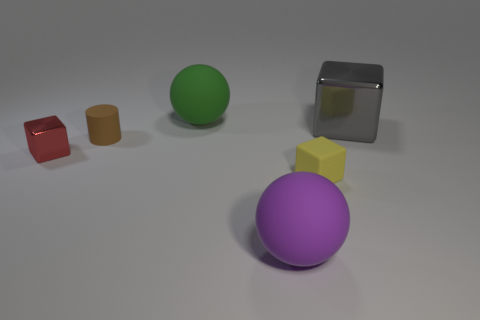Is there a tiny red block that has the same material as the big block?
Provide a short and direct response. Yes. What is the material of the red object that is the same size as the rubber cube?
Ensure brevity in your answer.  Metal. There is a matte object that is behind the small cylinder that is on the left side of the ball in front of the big block; what is its size?
Your answer should be very brief. Large. There is a rubber sphere in front of the tiny yellow cube; are there any big purple balls in front of it?
Your response must be concise. No. There is a tiny yellow object; is it the same shape as the shiny object left of the big green matte thing?
Keep it short and to the point. Yes. The small cube on the left side of the green matte sphere is what color?
Your response must be concise. Red. How big is the ball that is on the right side of the big matte ball behind the yellow cube?
Make the answer very short. Large. There is a gray metal object in front of the green matte object; is its shape the same as the tiny brown matte object?
Keep it short and to the point. No. There is a gray object that is the same shape as the tiny red thing; what is it made of?
Your answer should be very brief. Metal. How many things are large matte objects on the right side of the big green ball or blocks that are to the left of the green rubber ball?
Provide a short and direct response. 2. 